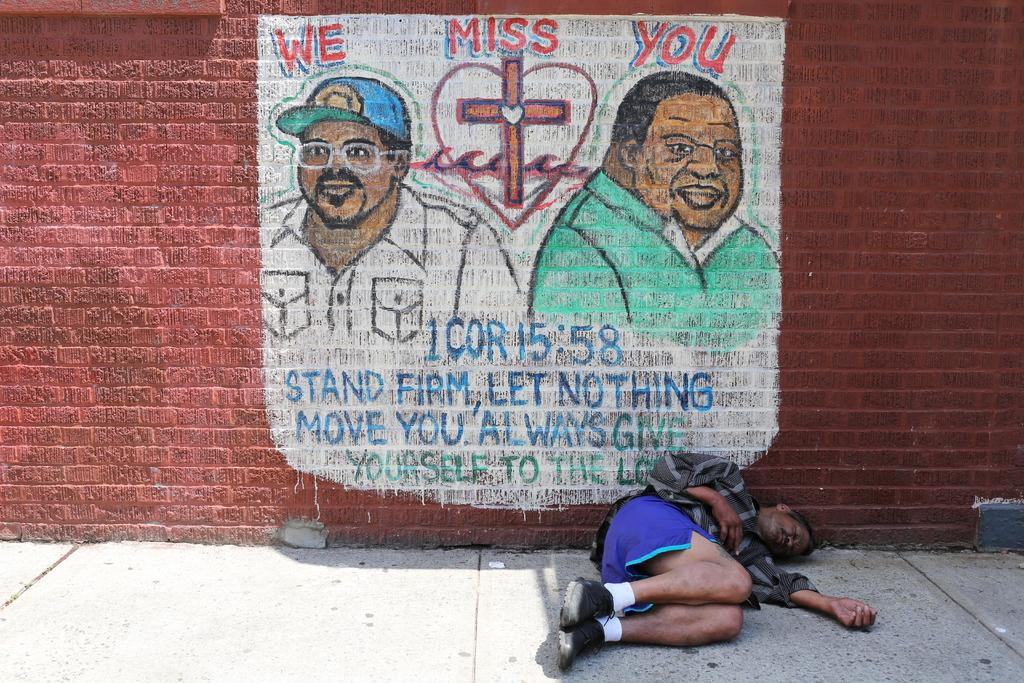<image>
Relay a brief, clear account of the picture shown. A man sleeps in front of a mural that says "we miss you." 